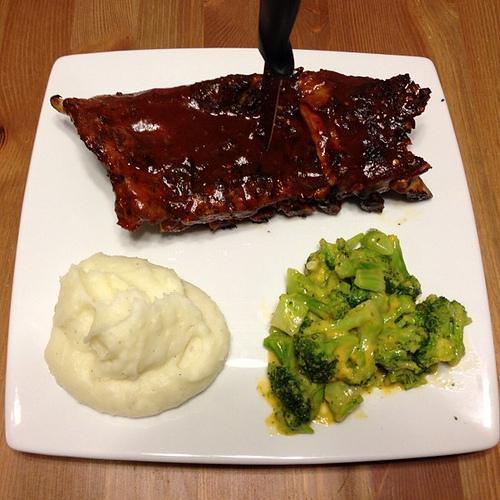How many different food items are on the plate?
Give a very brief answer. 3. 